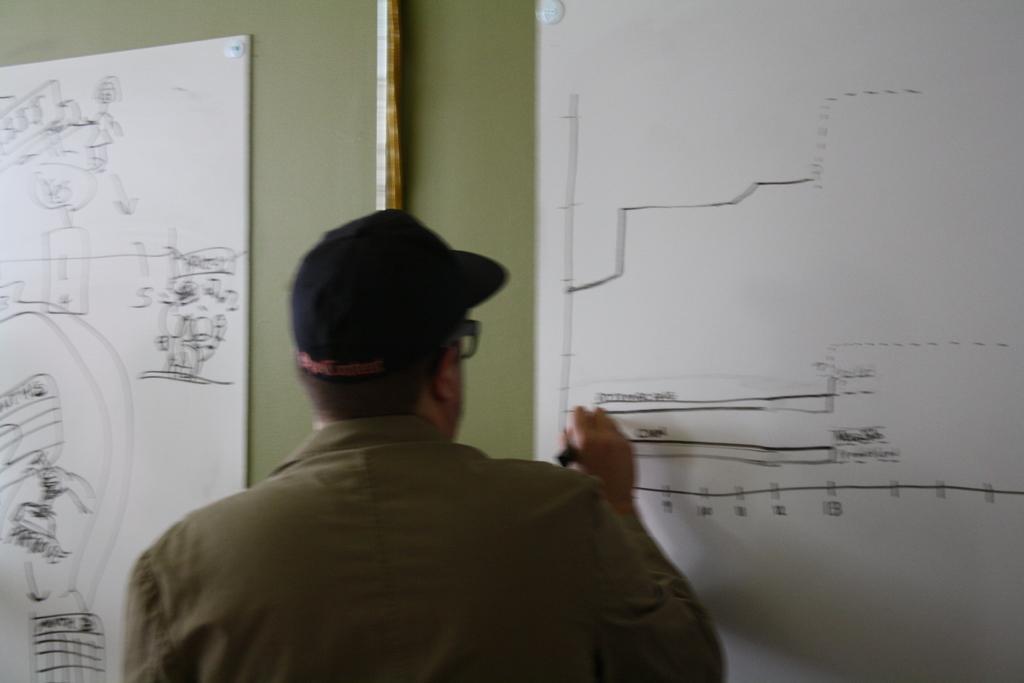How would you summarize this image in a sentence or two? In this picture, we see the man in the green shirt who is wearing the spectacles and a black cap is drawing something on the white chart or a white board. Behind that, we see a green wall. On the left side, we see a white chart or a white board on which something is drawn. 